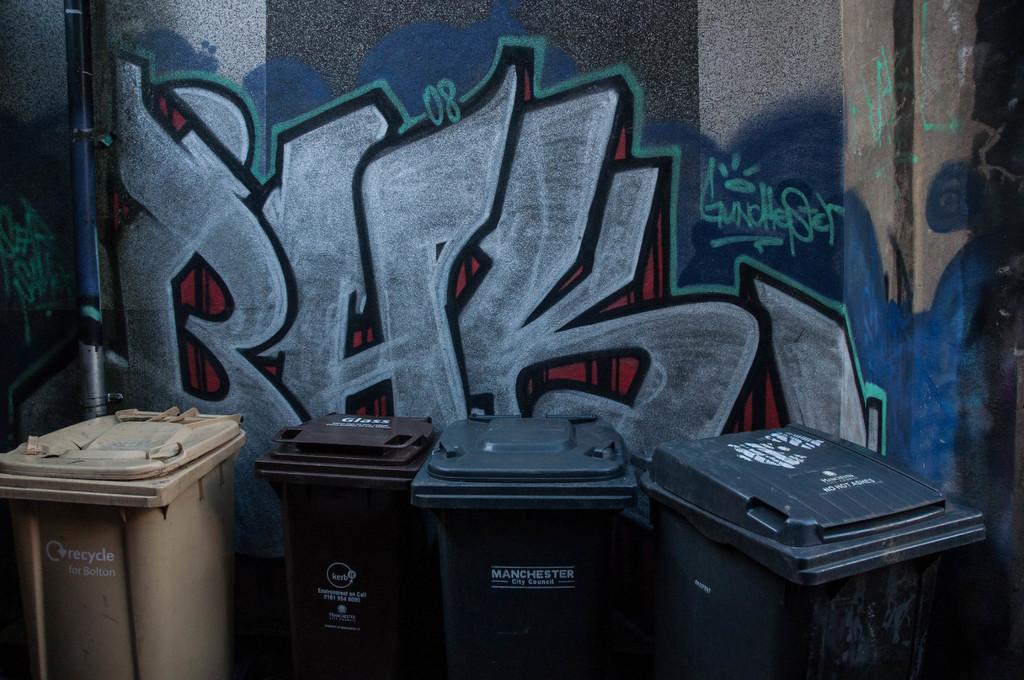Are these trash bins or recycle bins?
Provide a short and direct response. Recycle. 